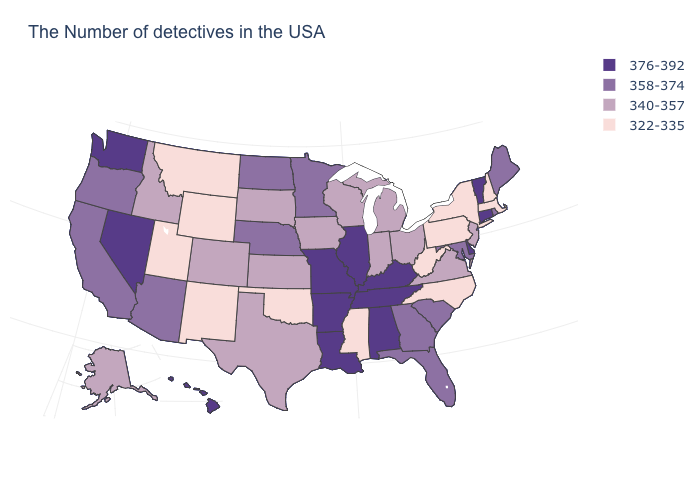Does Iowa have a higher value than Virginia?
Write a very short answer. No. What is the value of Rhode Island?
Short answer required. 358-374. Does the first symbol in the legend represent the smallest category?
Short answer required. No. Does Kansas have the highest value in the MidWest?
Concise answer only. No. What is the value of North Carolina?
Keep it brief. 322-335. What is the value of Kentucky?
Give a very brief answer. 376-392. Does California have a lower value than Connecticut?
Short answer required. Yes. What is the value of Vermont?
Answer briefly. 376-392. Name the states that have a value in the range 376-392?
Write a very short answer. Vermont, Connecticut, Delaware, Kentucky, Alabama, Tennessee, Illinois, Louisiana, Missouri, Arkansas, Nevada, Washington, Hawaii. Which states have the lowest value in the Northeast?
Short answer required. Massachusetts, New Hampshire, New York, Pennsylvania. Name the states that have a value in the range 322-335?
Short answer required. Massachusetts, New Hampshire, New York, Pennsylvania, North Carolina, West Virginia, Mississippi, Oklahoma, Wyoming, New Mexico, Utah, Montana. What is the lowest value in states that border Michigan?
Keep it brief. 340-357. Among the states that border Illinois , which have the lowest value?
Give a very brief answer. Indiana, Wisconsin, Iowa. Name the states that have a value in the range 358-374?
Short answer required. Maine, Rhode Island, Maryland, South Carolina, Florida, Georgia, Minnesota, Nebraska, North Dakota, Arizona, California, Oregon. 